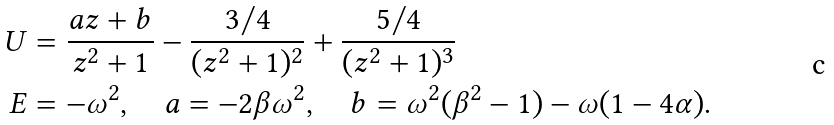Convert formula to latex. <formula><loc_0><loc_0><loc_500><loc_500>U & = \frac { a z + b } { z ^ { 2 } + 1 } - \frac { 3 / 4 } { ( z ^ { 2 } + 1 ) ^ { 2 } } + \frac { 5 / 4 } { ( z ^ { 2 } + 1 ) ^ { 3 } } \\ E & = - \omega ^ { 2 } , \quad a = - 2 \beta \omega ^ { 2 } , \quad b = \omega ^ { 2 } ( \beta ^ { 2 } - 1 ) - \omega ( 1 - 4 \alpha ) .</formula> 